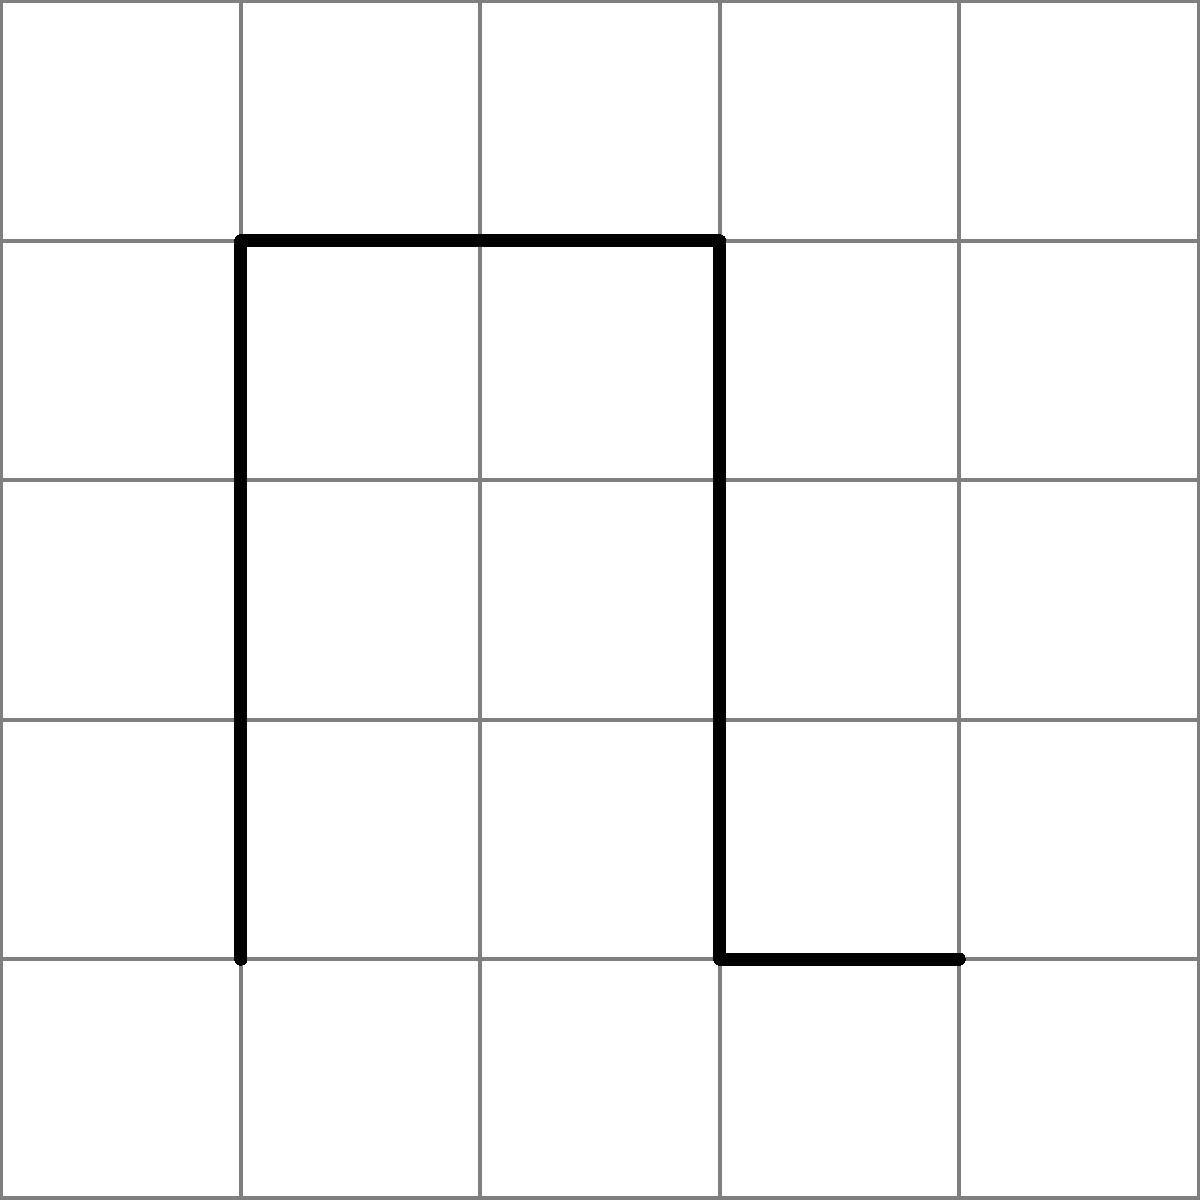In a grid-based puzzle game, you need to find the optimal path from start (S) to end (E) in the given 6x6 maze. The path can only move horizontally or vertically, and cannot pass through walls. What is the minimum number of steps required to reach the end point? Let's solve this step-by-step:

1) First, we need to identify the possible paths:
   - The maze has walls that restrict movement, so we need to find a path around them.

2) The optimal path will be the shortest one that avoids all walls:
   - Start at (0,0)
   - Move right 2 steps to (2,0)
   - Move up 5 steps to (2,5)
   - Move right 3 steps to (5,5)

3) Count the total steps:
   - Right movement: 2 + 3 = 5 steps
   - Up movement: 5 steps

4) Sum up the total steps:
   $$ \text{Total steps} = \text{Right steps} + \text{Up steps} $$
   $$ \text{Total steps} = 5 + 5 = 10 $$

Therefore, the minimum number of steps required to reach the end point is 10.
Answer: 10 steps 